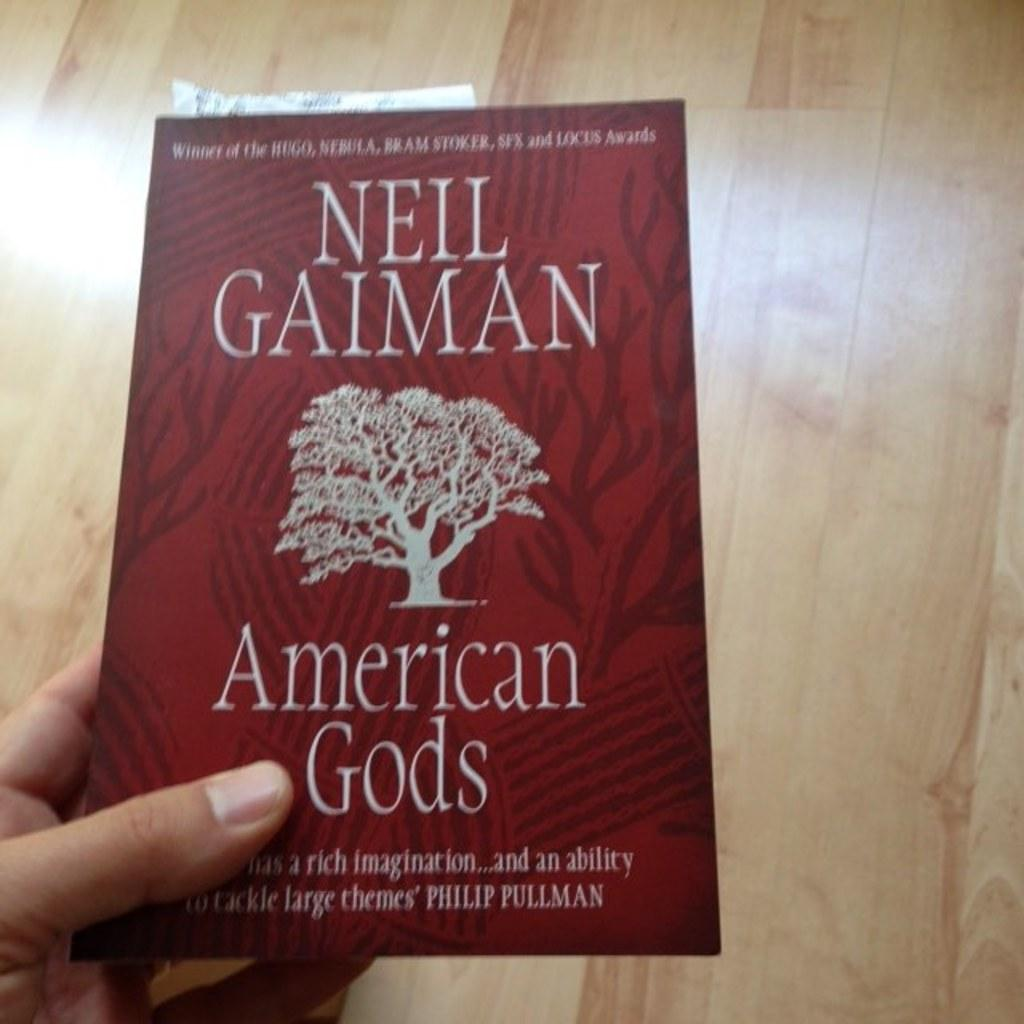Provide a one-sentence caption for the provided image. A hand holds a red book called American Gods by Neil Gaiman above a wooden floor. 